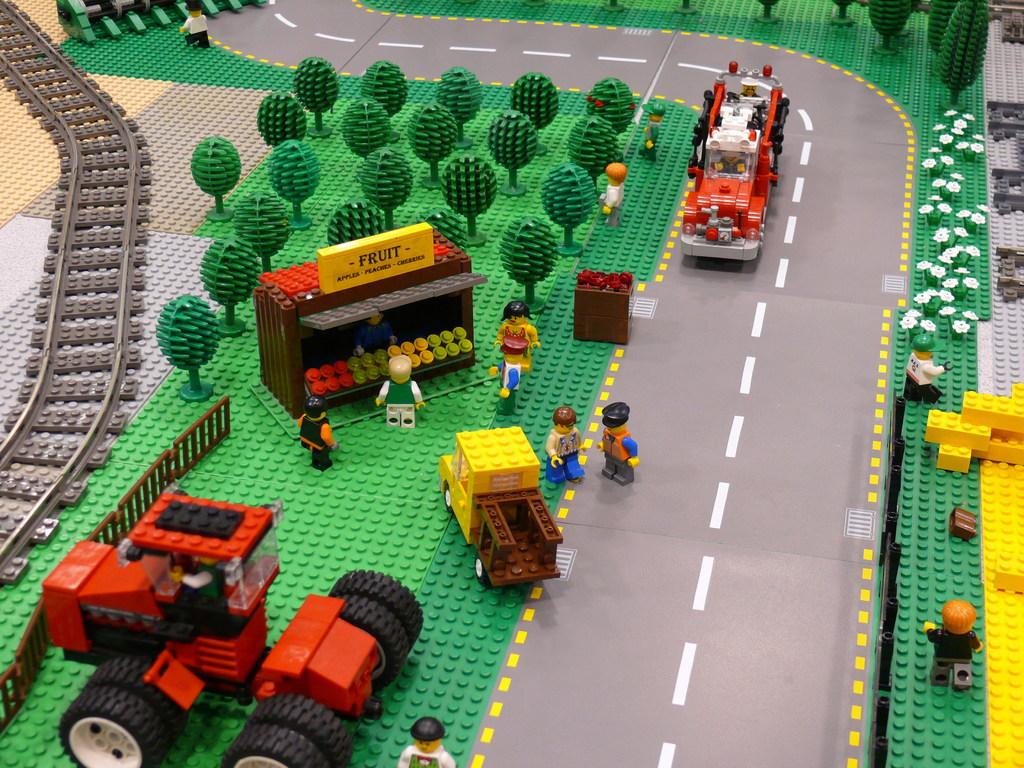What kind of stand is this?
Make the answer very short. Fruit. Does the stand sell apples?
Offer a very short reply. Yes. 